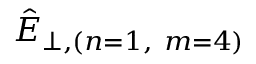<formula> <loc_0><loc_0><loc_500><loc_500>\hat { E } _ { \bot , ( n = 1 , \ m = 4 ) }</formula> 